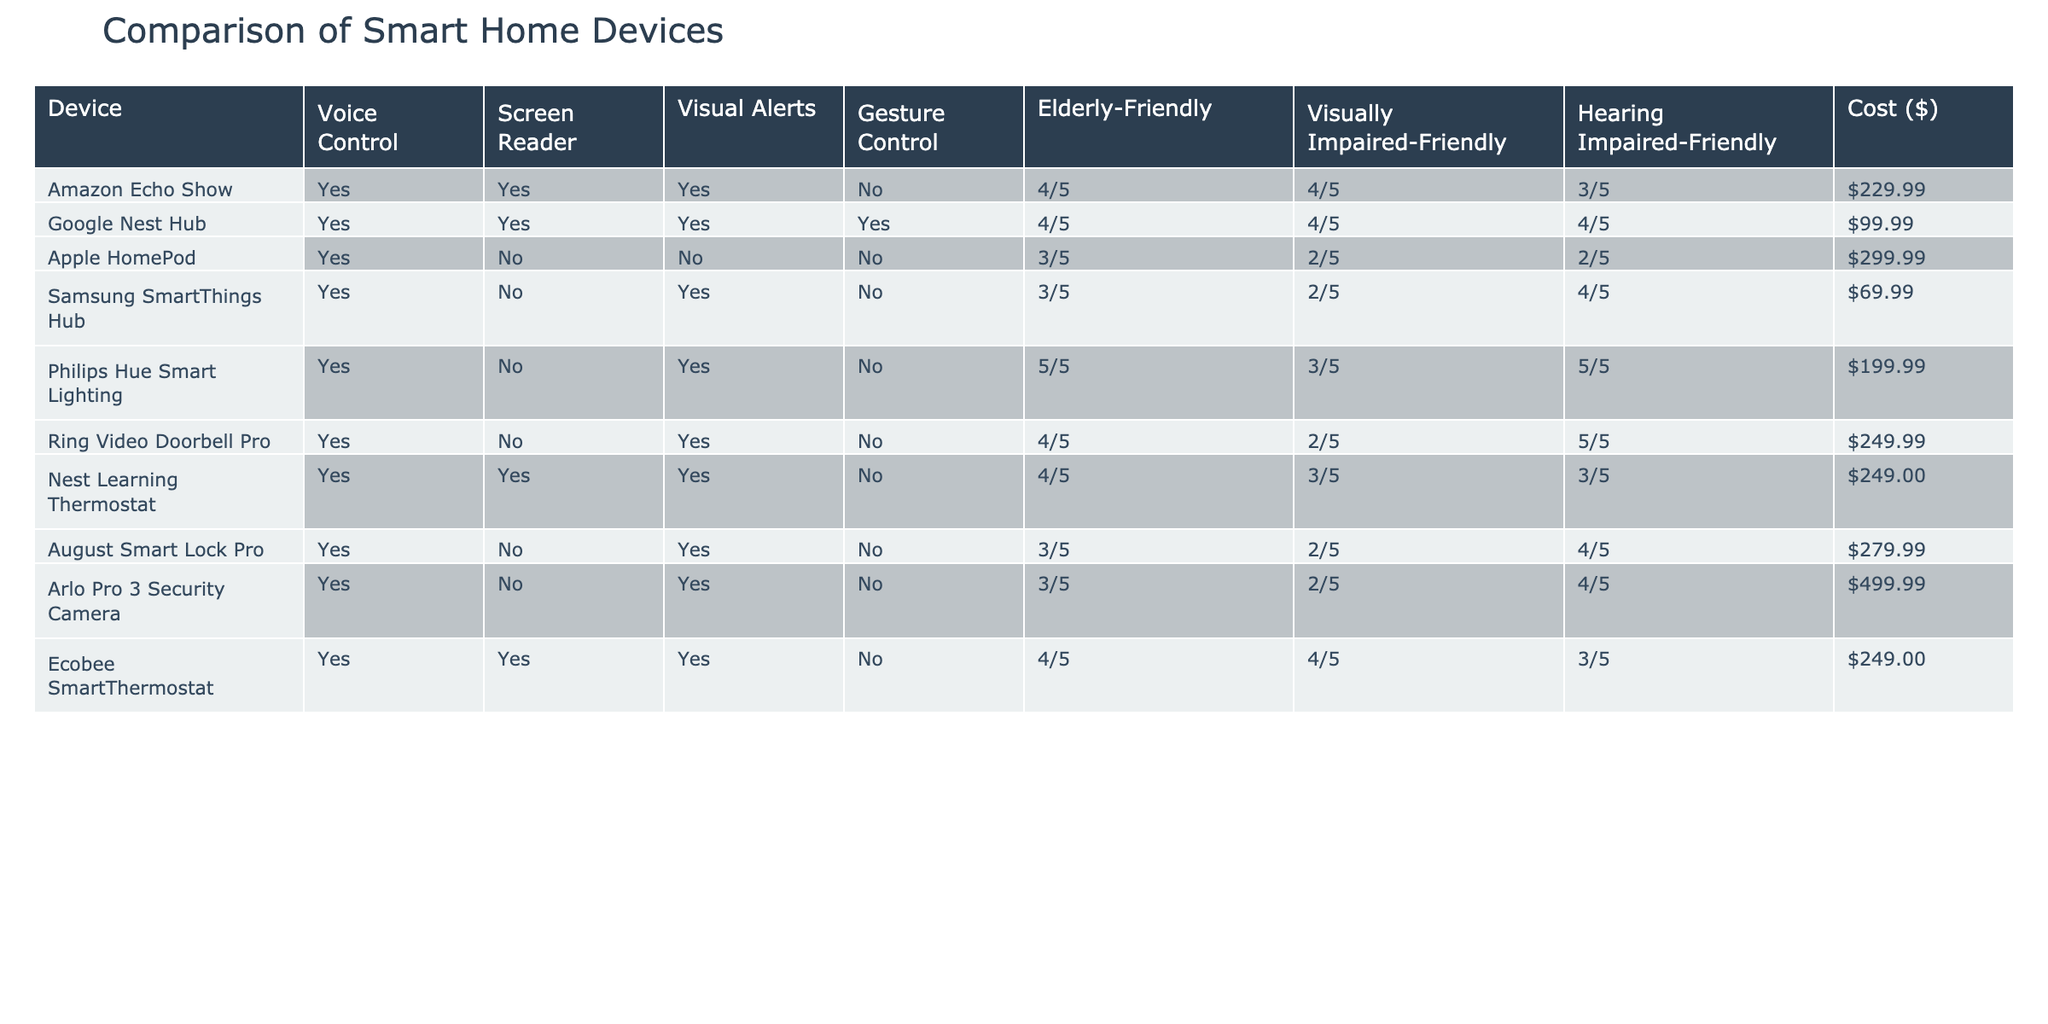What smart home device has the highest rating for elderly-friendly usability? Looking through the table, the Philips Hue Smart Lighting has the highest rating of 5/5 for elderly-friendly usability compared to other devices.
Answer: Philips Hue Smart Lighting Which devices in the table support gesture control? From the table, only the Google Nest Hub supports gesture control as it is the only device marked with 'Yes' under the Gesture Control column.
Answer: Google Nest Hub How many devices offer both voice control and screen reader support? By counting the devices in the table, we see that four devices (Amazon Echo Show, Google Nest Hub, Nest Learning Thermostat, and Ecobee SmartThermostat) have 'Yes' marked in both the Voice Control and Screen Reader columns.
Answer: 4 What is the cost difference between the most and least expensive devices? The most expensive device is the Arlo Pro 3 Security Camera at $499.99, and the least expensive device is the Samsung SmartThings Hub at $69.99. The cost difference is calculated by subtracting the lowest price from the highest price: $499.99 - $69.99 = $430.00.
Answer: $430.00 Are there any devices that provide visual alerts for users with hearing impairments? Checking the table, the devices that provide visual alerts for users with hearing impairments are: Ring Video Doorbell Pro, Samsung SmartThings Hub, and Philips Hue Smart Lighting, each of which has 'Yes' in the Visual Alerts column and ratings for Hearing Impaired-Friendly.
Answer: Yes 